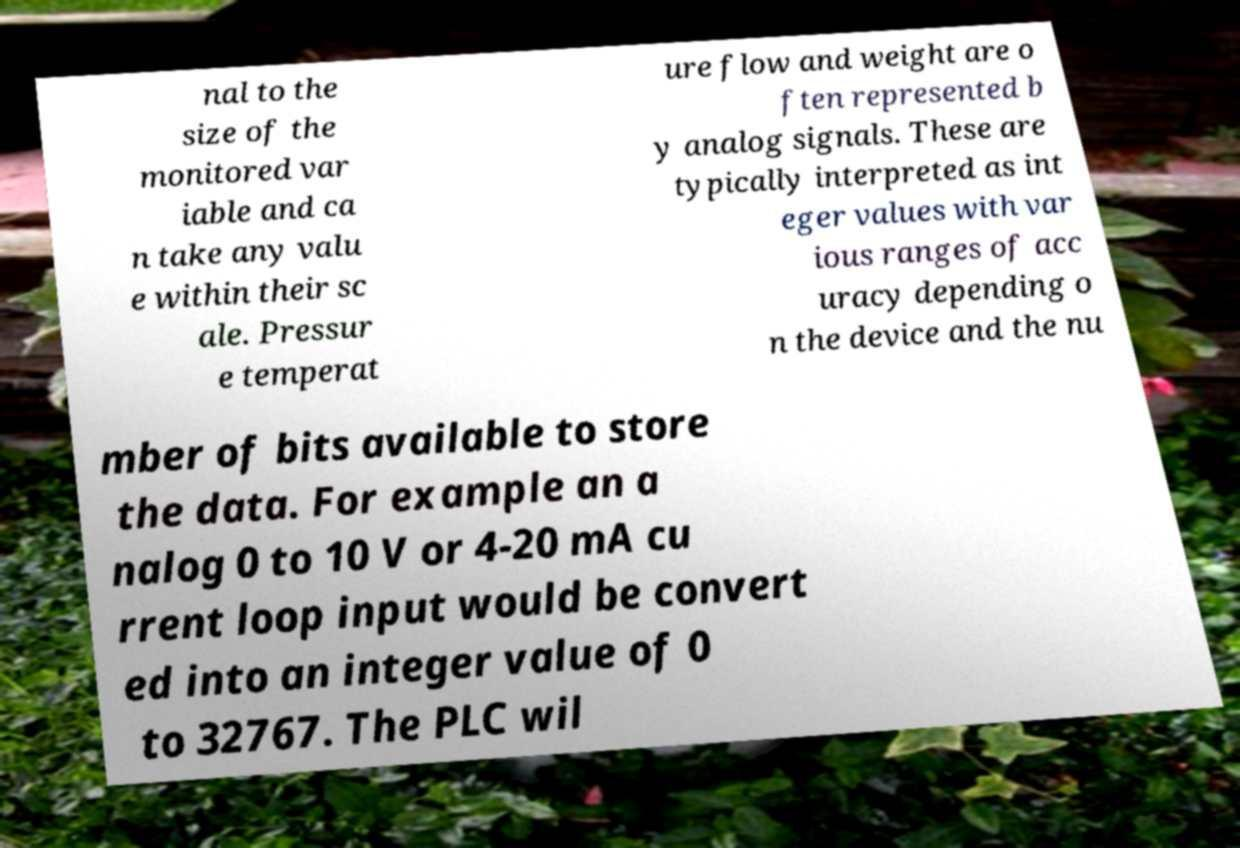Please identify and transcribe the text found in this image. nal to the size of the monitored var iable and ca n take any valu e within their sc ale. Pressur e temperat ure flow and weight are o ften represented b y analog signals. These are typically interpreted as int eger values with var ious ranges of acc uracy depending o n the device and the nu mber of bits available to store the data. For example an a nalog 0 to 10 V or 4-20 mA cu rrent loop input would be convert ed into an integer value of 0 to 32767. The PLC wil 